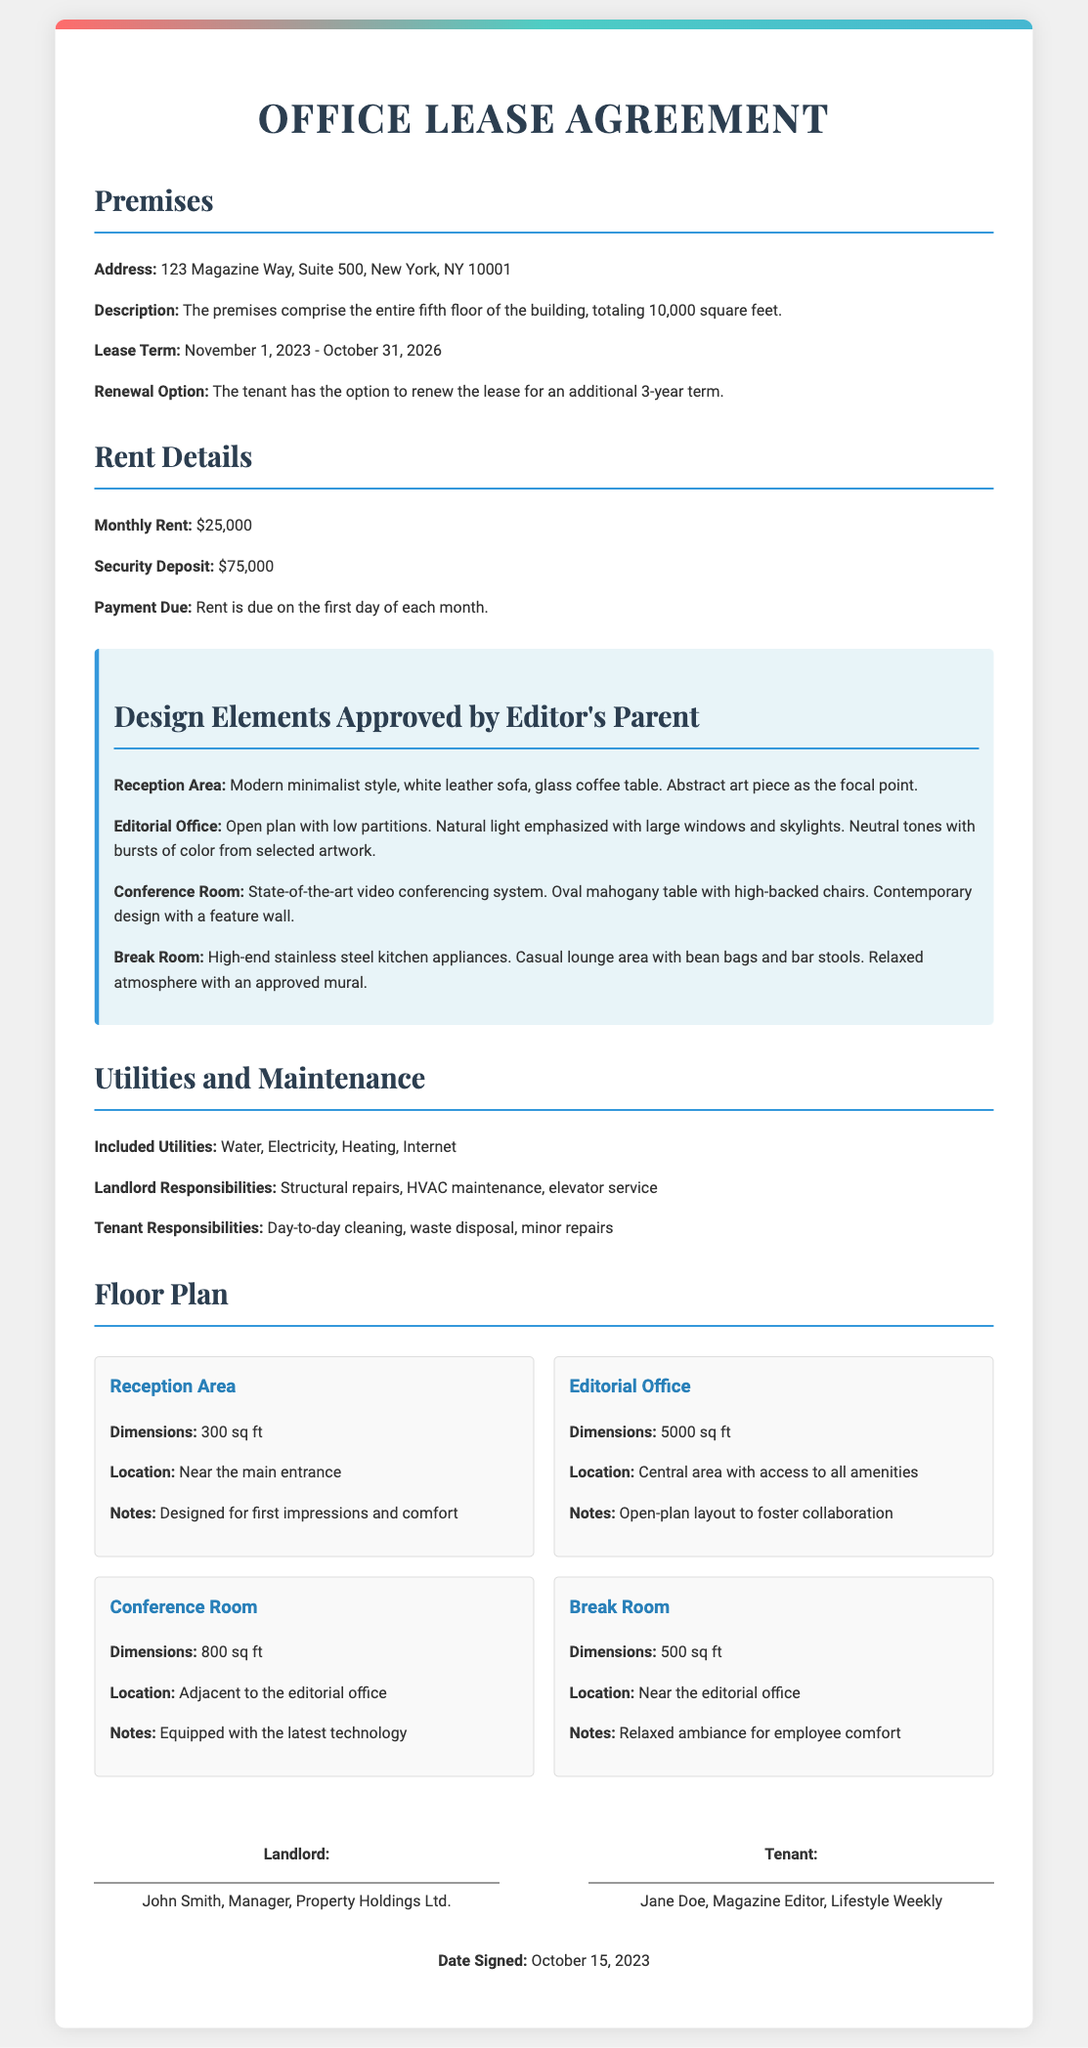what is the address of the magazine headquarters? The address is specified in the document under the "Premises" section as 123 Magazine Way, Suite 500, New York, NY 10001.
Answer: 123 Magazine Way, Suite 500, New York, NY 10001 what is the monthly rent for the lease? The monthly rent is given in the "Rent Details" section as $25,000.
Answer: $25,000 how long is the lease term? The lease term is mentioned in the document as November 1, 2023 - October 31, 2026, totaling 3 years.
Answer: November 1, 2023 - October 31, 2026 which room is designed as the first impressions area? The room highlighted for first impressions and comfort is the reception area.
Answer: Reception Area what notable feature is in the conference room? The notable feature in the conference room is a state-of-the-art video conferencing system.
Answer: Video conferencing system what is the total area of the editorial office? The total area of the editorial office is specified in the document as 5000 sq ft.
Answer: 5000 sq ft who is listed as the landlord in the signatures section? The landlord's name is mentioned in the signatures section as John Smith.
Answer: John Smith what additional term does the tenant have after the initial lease period? The tenant has the option to renew the lease for an additional 3-year term.
Answer: Renew for 3 years which kitchen appliances are specified for the break room? The break room is mentioned to have high-end stainless steel kitchen appliances.
Answer: Stainless steel kitchen appliances 